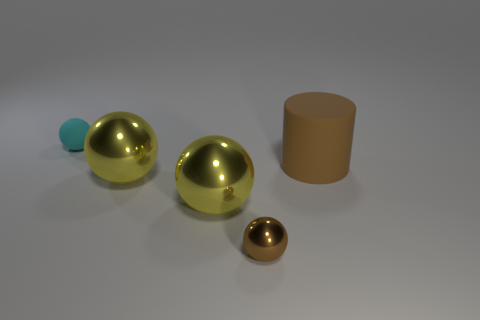There is another cyan thing that is the same shape as the small shiny object; what size is it?
Provide a succinct answer. Small. There is a small object that is in front of the tiny cyan rubber ball; what is its shape?
Give a very brief answer. Sphere. There is a small object in front of the brown thing that is behind the small brown object; what color is it?
Ensure brevity in your answer.  Brown. What number of things are small spheres in front of the cyan matte object or small blue rubber spheres?
Keep it short and to the point. 1. There is a cylinder; does it have the same size as the rubber object to the left of the brown metallic object?
Your answer should be compact. No. What number of big objects are green matte cubes or cyan matte objects?
Make the answer very short. 0. What shape is the tiny cyan rubber thing?
Offer a terse response. Sphere. What is the size of the object that is the same color as the rubber cylinder?
Provide a succinct answer. Small. Is there another ball that has the same material as the brown sphere?
Keep it short and to the point. Yes. Is the number of large objects greater than the number of tiny red metal things?
Make the answer very short. Yes. 